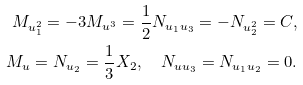<formula> <loc_0><loc_0><loc_500><loc_500>M _ { u _ { 1 } ^ { 2 } } = - 3 M _ { u ^ { 3 } } = \frac { 1 } { 2 } N _ { u _ { 1 } u _ { 3 } } = - N _ { u _ { 2 } ^ { 2 } } = C , \\ M _ { u } = N _ { u _ { 2 } } = \frac { 1 } { 3 } X _ { 2 } , \quad N _ { u u _ { 3 } } = N _ { u _ { 1 } u _ { 2 } } = 0 .</formula> 